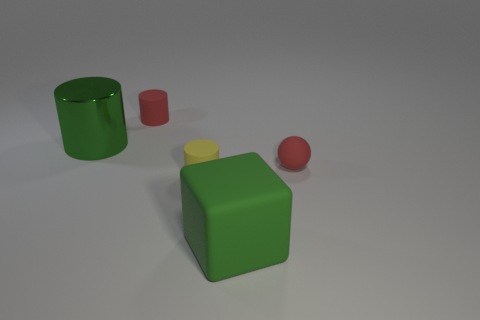Add 4 large red matte spheres. How many objects exist? 9 Subtract all blocks. How many objects are left? 4 Add 3 large green blocks. How many large green blocks are left? 4 Add 4 tiny rubber balls. How many tiny rubber balls exist? 5 Subtract 1 yellow cylinders. How many objects are left? 4 Subtract all red matte cubes. Subtract all small red rubber spheres. How many objects are left? 4 